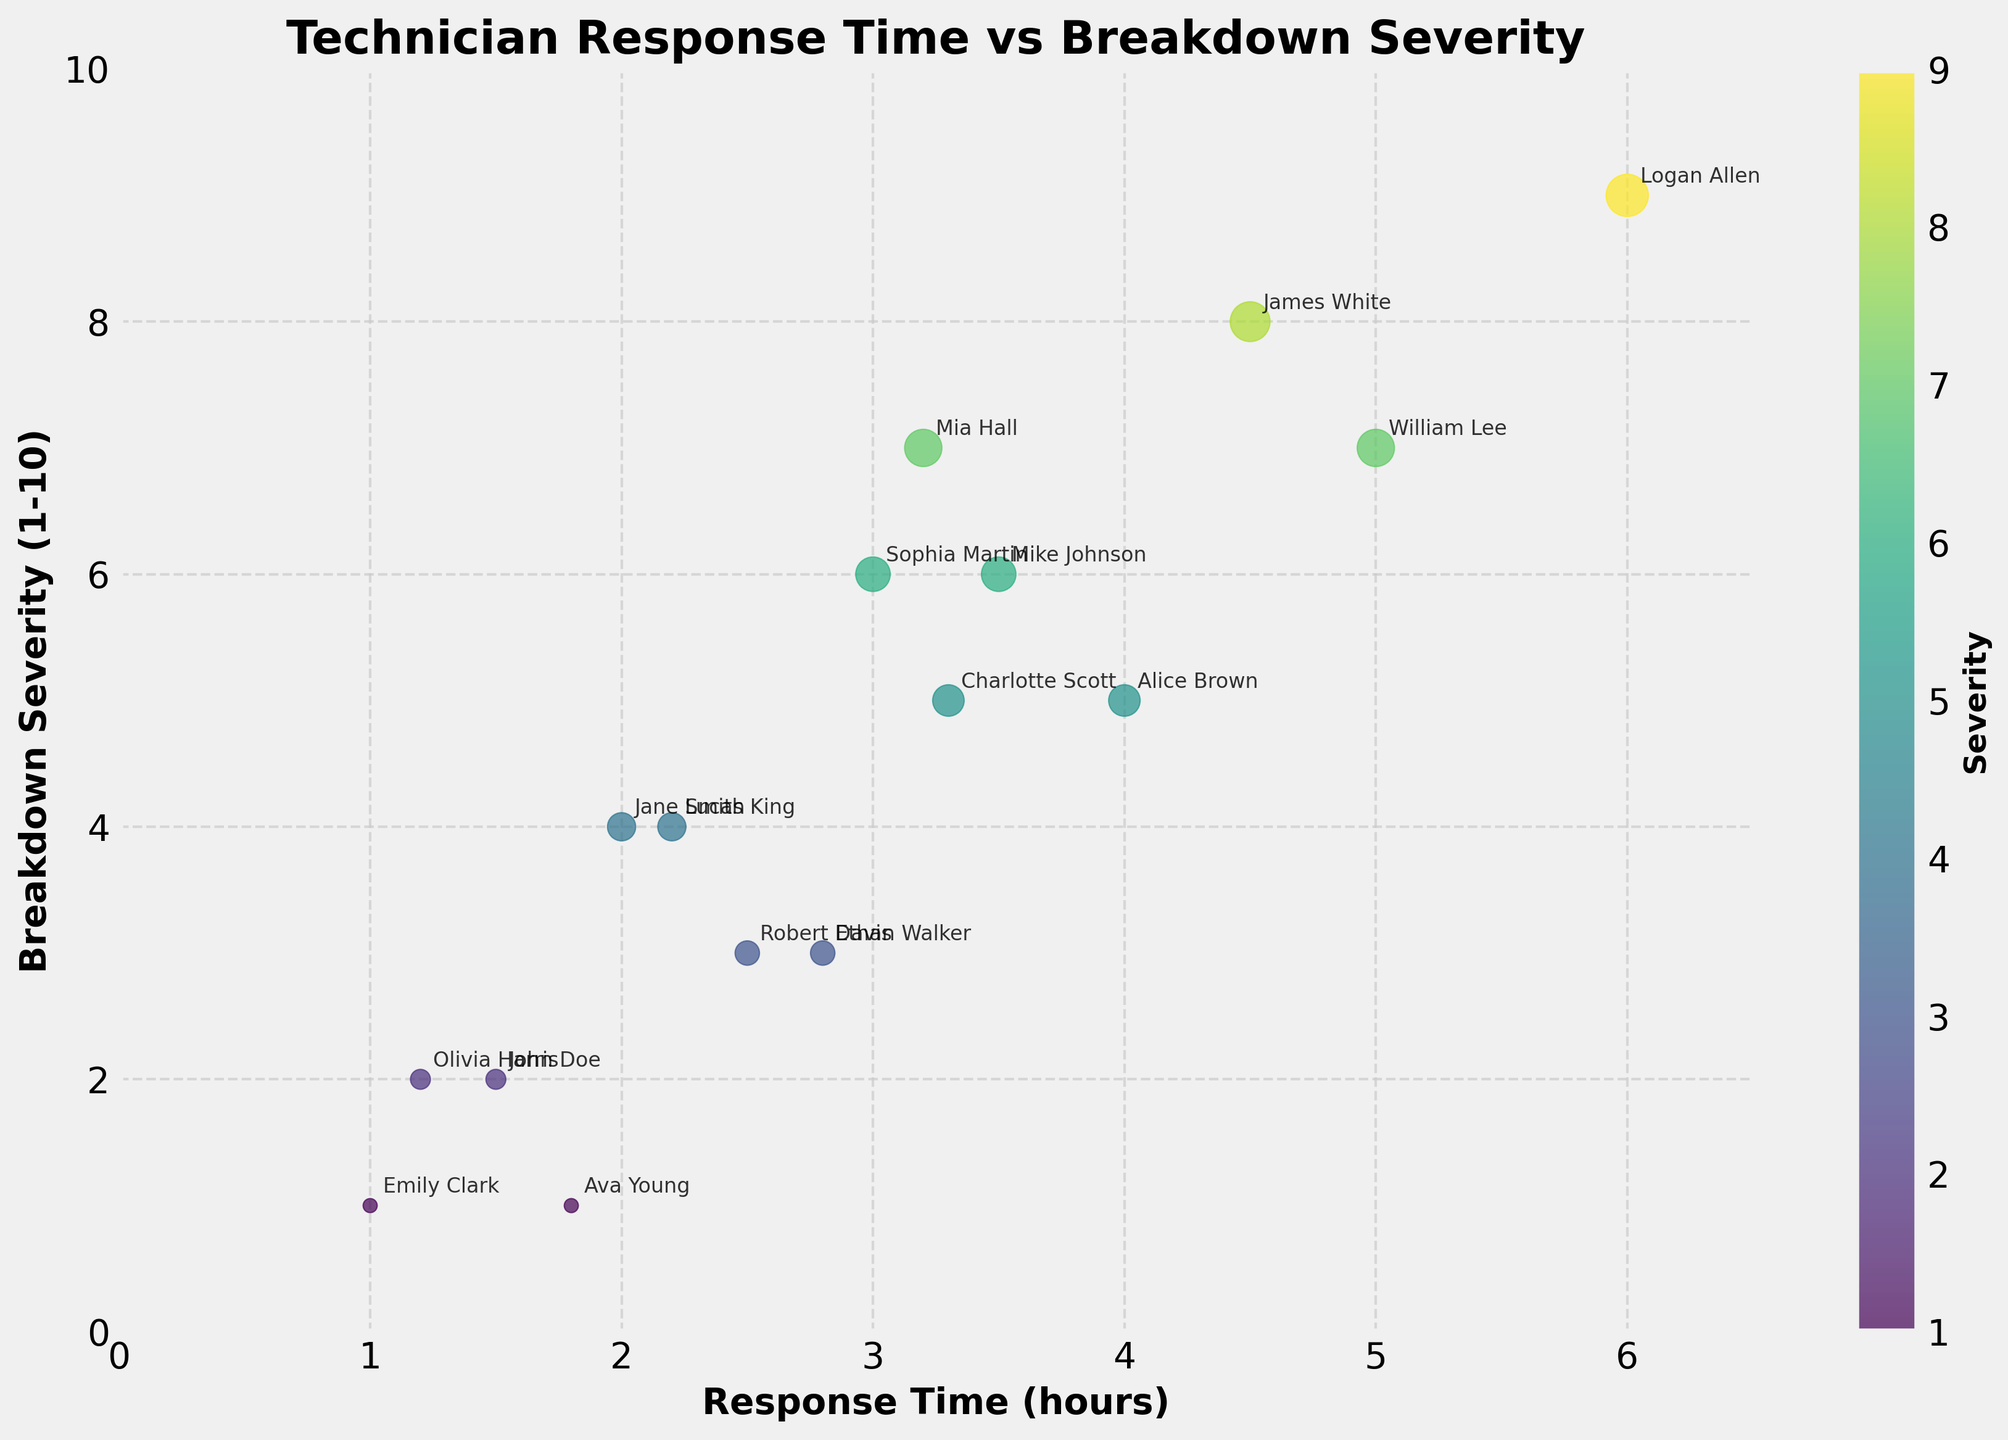What is the title of the scatter plot? The title of the scatter plot is displayed at the top of the figure in bold text.
Answer: Technician Response Time vs Breakdown Severity What is the range of the x-axis? The x-axis represents Response Time (hours) and its range can be observed from 0 to just beyond the maximum response time.
Answer: 0 to approximately 6.5 hours How many technicians responded within 2 hours? To determine how many technicians responded within 2 hours, count the data points where the response time is equal to or less than 2 hours. Technicians: John Doe (1.5), Jane Smith (2.0), Emily Clark (1.0), Olivia Harris (1.2), Ava Young (1.8)
Answer: 5 Which technician had the quickest response time for a breakdown with severity 6? Locate the data points where Breakdown Severity is 6, then identify the technician with the smallest response time.
Answer: Mike Johnson Compare the response times of Sophia Martin and Charlotte Scott. Who responded quicker and by how much? Look for the response times of Sophia Martin (3.0 hours) and Charlotte Scott (3.3 hours). Calculate the difference. 3.3 - 3 = 0.3
Answer: Sophia Martin, by 0.3 hours What pattern can be observed between response time and breakdown severity? Examine the scatter plot to see if there is any visible trend between the two variables. The general trend can be deduced by observing the distribution of data points.
Answer: Response time tends to increase with breakdown severity Who responded to the most severe breakdown, and what was their response time? Identify the data point with the highest breakdown severity (10). Observe the accompanying technician's name and their response time. Technician: Logan Allen, Response Time: 6.0 hours
Answer: Logan Allen, 6.0 hours What is the average response time for breakdowns with severity greater than 5? List the response times for breakdowns with severity greater than 5: Mike Johnson (3.5), William Lee (5.0), Sophia Martin (3.0), Mia Hall (3.2), James White (4.5), Logan Allen (6.0). Calculate the average. (3.5 + 5.0 + 3.0 + 3.2 + 4.5 + 6.0) / 6 = 25.2 / 6
Answer: 4.2 hours Is there any technician who has responded to a breakdown severity of 4? Determine if any data point corresponds to a breakdown severity of exactly 4.
Answer: Yes, Jane Smith and Lucas King What is the severity range of breakdowns that Robert Davis handled? Find the breakdown severities associated with Robert Davis.
Answer: 3 